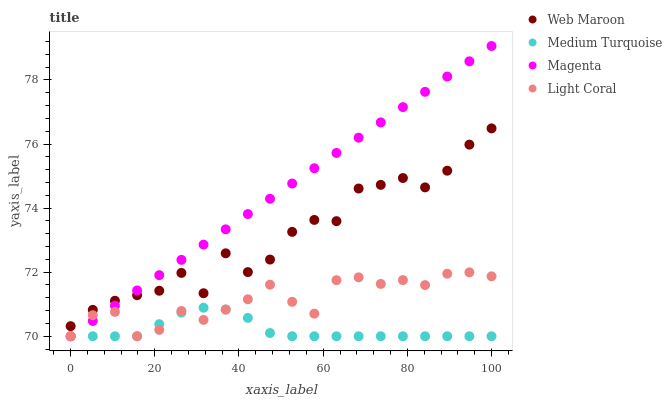Does Medium Turquoise have the minimum area under the curve?
Answer yes or no. Yes. Does Magenta have the maximum area under the curve?
Answer yes or no. Yes. Does Web Maroon have the minimum area under the curve?
Answer yes or no. No. Does Web Maroon have the maximum area under the curve?
Answer yes or no. No. Is Magenta the smoothest?
Answer yes or no. Yes. Is Web Maroon the roughest?
Answer yes or no. Yes. Is Web Maroon the smoothest?
Answer yes or no. No. Is Magenta the roughest?
Answer yes or no. No. Does Light Coral have the lowest value?
Answer yes or no. Yes. Does Web Maroon have the lowest value?
Answer yes or no. No. Does Magenta have the highest value?
Answer yes or no. Yes. Does Web Maroon have the highest value?
Answer yes or no. No. Is Medium Turquoise less than Web Maroon?
Answer yes or no. Yes. Is Web Maroon greater than Medium Turquoise?
Answer yes or no. Yes. Does Medium Turquoise intersect Light Coral?
Answer yes or no. Yes. Is Medium Turquoise less than Light Coral?
Answer yes or no. No. Is Medium Turquoise greater than Light Coral?
Answer yes or no. No. Does Medium Turquoise intersect Web Maroon?
Answer yes or no. No. 